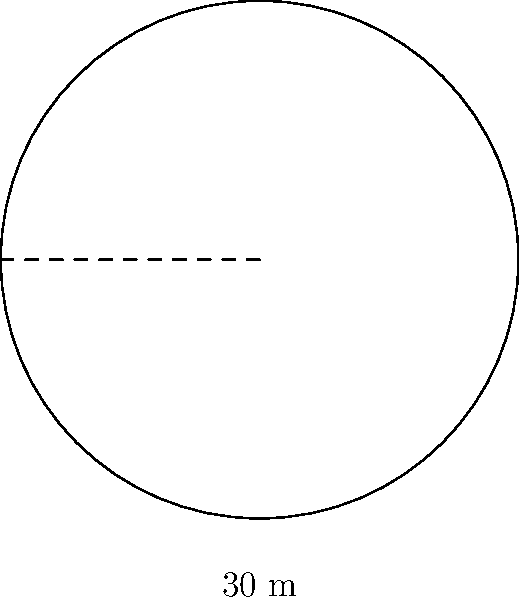As the village chief, you're planning a circular gathering space for community events. The space has a diameter of 30 meters. What is the perimeter of this circular area, rounded to the nearest meter? To find the perimeter of a circular area, we need to calculate its circumference. Let's approach this step-by-step:

1) The formula for the circumference of a circle is:
   $$C = 2\pi r$$
   where $C$ is the circumference, $\pi$ is pi, and $r$ is the radius.

2) We're given the diameter, which is 30 meters. The radius is half of the diameter:
   $$r = \frac{30}{2} = 15 \text{ meters}$$

3) Now we can plug this into our circumference formula:
   $$C = 2\pi(15)$$

4) Let's use 3.14159 as an approximation for $\pi$:
   $$C = 2(3.14159)(15) = 94.24777 \text{ meters}$$

5) Rounding to the nearest meter:
   $$C \approx 94 \text{ meters}$$

Therefore, the perimeter of the circular gathering space is approximately 94 meters.
Answer: 94 meters 